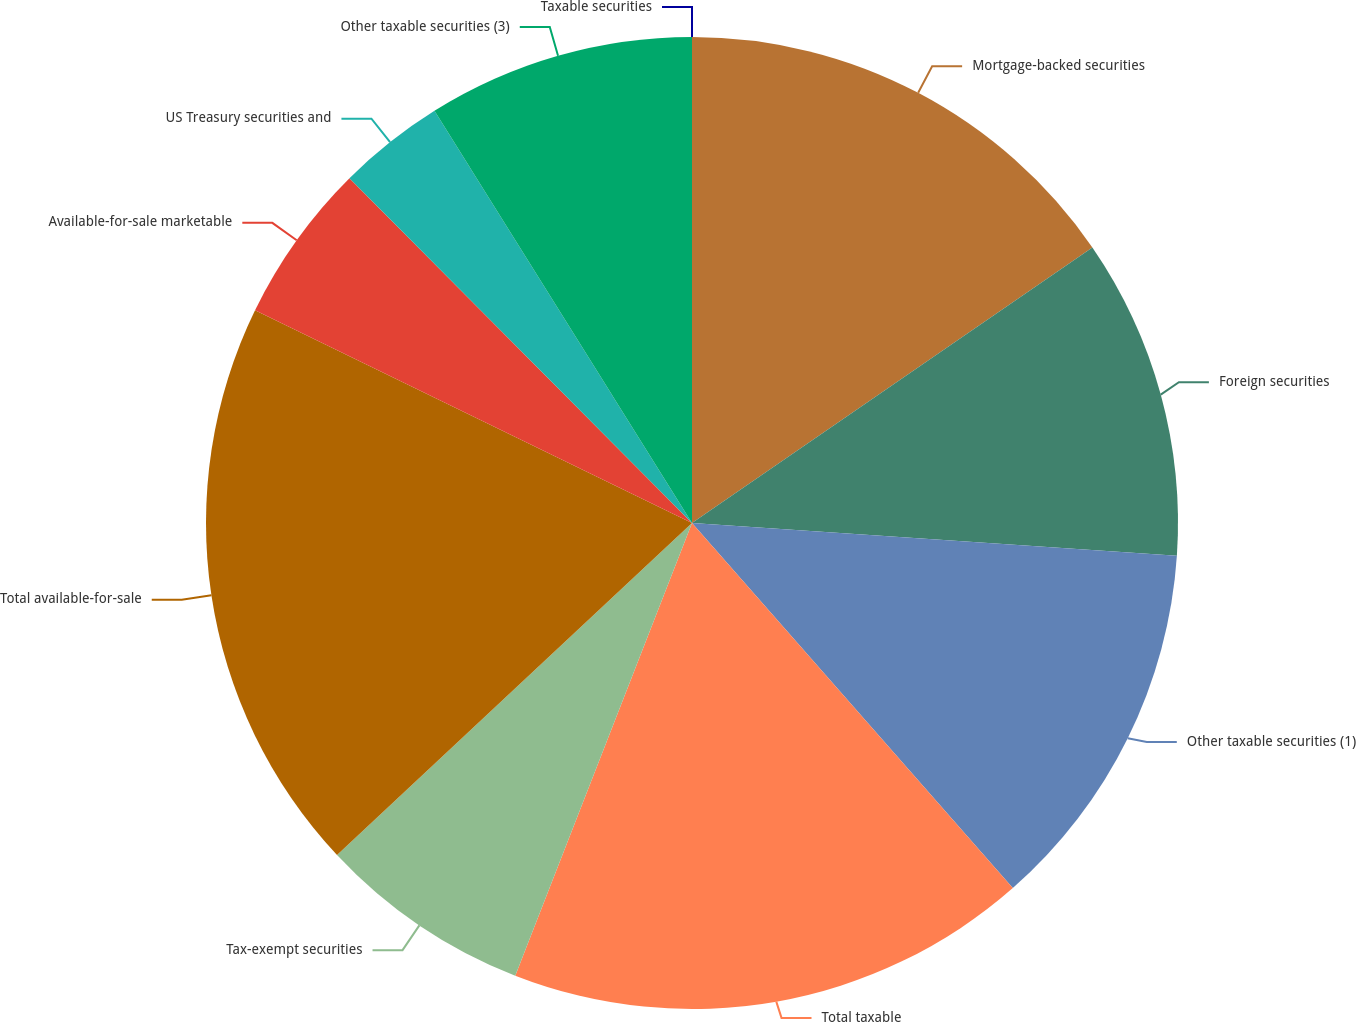<chart> <loc_0><loc_0><loc_500><loc_500><pie_chart><fcel>Mortgage-backed securities<fcel>Foreign securities<fcel>Other taxable securities (1)<fcel>Total taxable<fcel>Tax-exempt securities<fcel>Total available-for-sale<fcel>Available-for-sale marketable<fcel>US Treasury securities and<fcel>Other taxable securities (3)<fcel>Taxable securities<nl><fcel>15.41%<fcel>10.67%<fcel>12.45%<fcel>17.4%<fcel>7.11%<fcel>19.18%<fcel>5.34%<fcel>3.56%<fcel>8.89%<fcel>0.0%<nl></chart> 